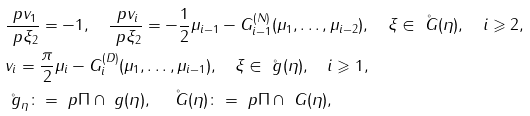<formula> <loc_0><loc_0><loc_500><loc_500>& \frac { \ p v _ { 1 } } { \ p \xi _ { 2 } } = - 1 , \quad \frac { \ p v _ { i } } { \ p \xi _ { 2 } } = - \frac { 1 } { 2 } \mu _ { i - 1 } - G _ { i - 1 } ^ { ( N ) } ( \mu _ { 1 } , \dots , \mu _ { i - 2 } ) , \quad \xi \in \mathring { \ G } ( \eta ) , \quad i \geqslant 2 , \\ & v _ { i } = \frac { \pi } { 2 } \mu _ { i } - G _ { i } ^ { ( D ) } ( \mu _ { 1 } , \dots , \mu _ { i - 1 } ) , \quad \xi \in \mathring { \ g } ( \eta ) , \quad i \geqslant 1 , \\ & \mathring { \ g } _ { \eta } \colon = \ p \Pi \cap \ g ( \eta ) , \quad \mathring { \ G } ( \eta ) \colon = \ p \Pi \cap \ G ( \eta ) ,</formula> 